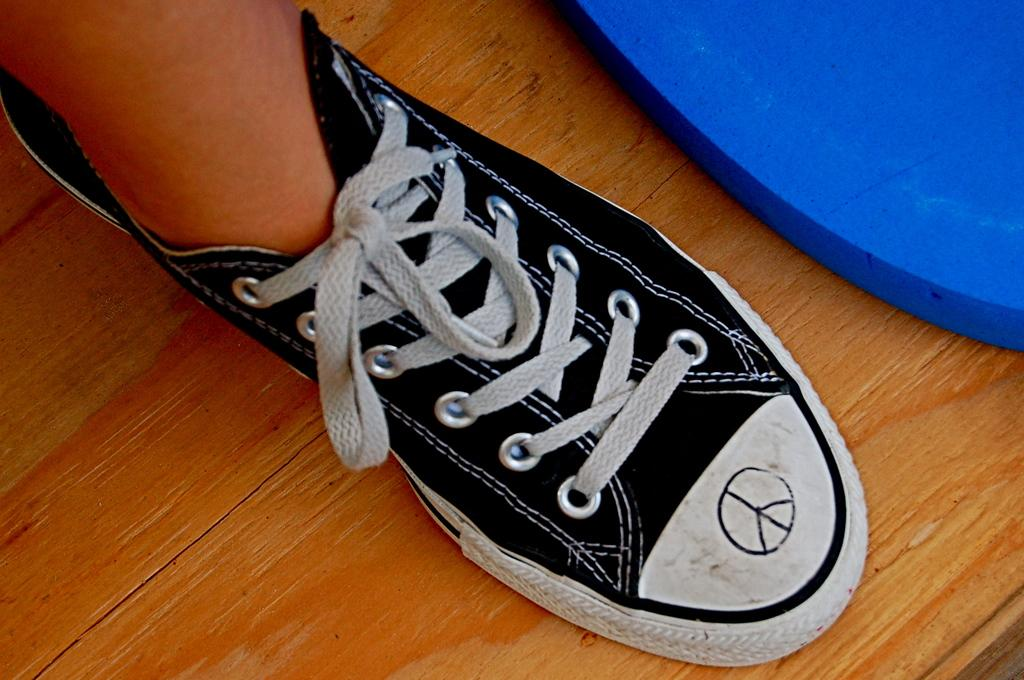What is present in the image? There is a person in the image. What is the person wearing on their foot? The person is wearing a shoe. On what surface is the shoe placed? The shoe is placed on a wooden surface. What color is the object in the image? There is a violet color object in the image. How does the person in the image act when crossing the bridge? There is no bridge present in the image, so the person's actions while crossing a bridge cannot be determined. 